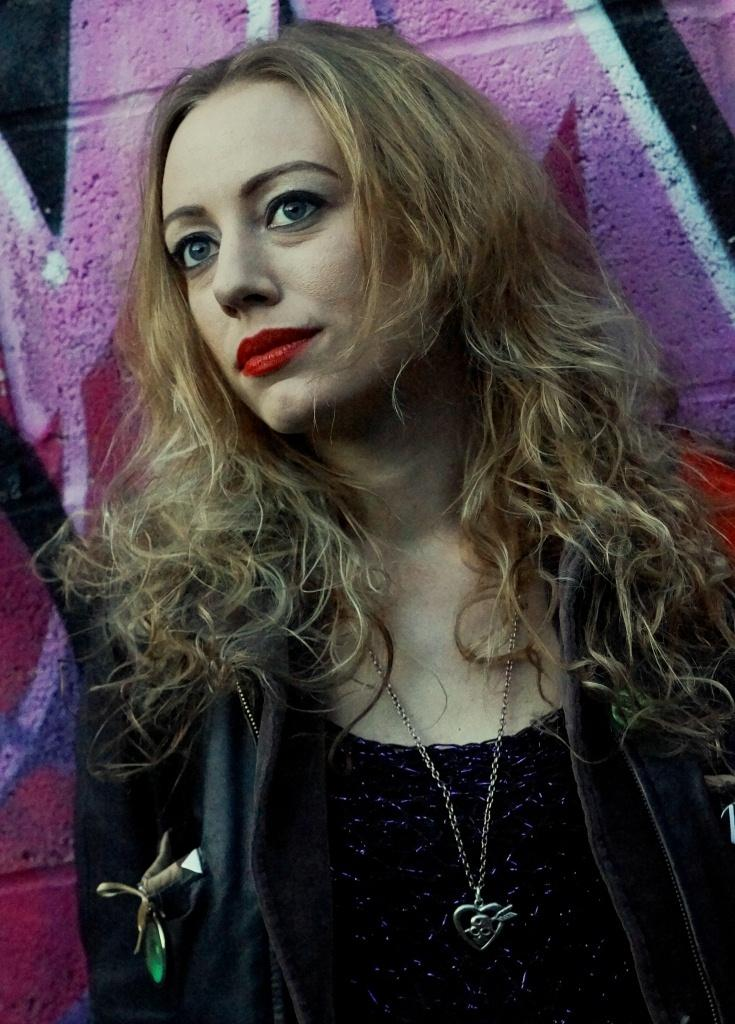Who is present in the image? There is a woman in the image. What is the woman wearing? The woman is wearing a black dress and a necklace. What can be seen in the background of the image? There is a wall in the background of the image. What is depicted on the wall? The wall has a pink color painting on it. What offer is the woman making in the image? There is no offer being made in the image; it simply shows a woman wearing a black dress and a necklace, with a pink painting on the wall in the background. 